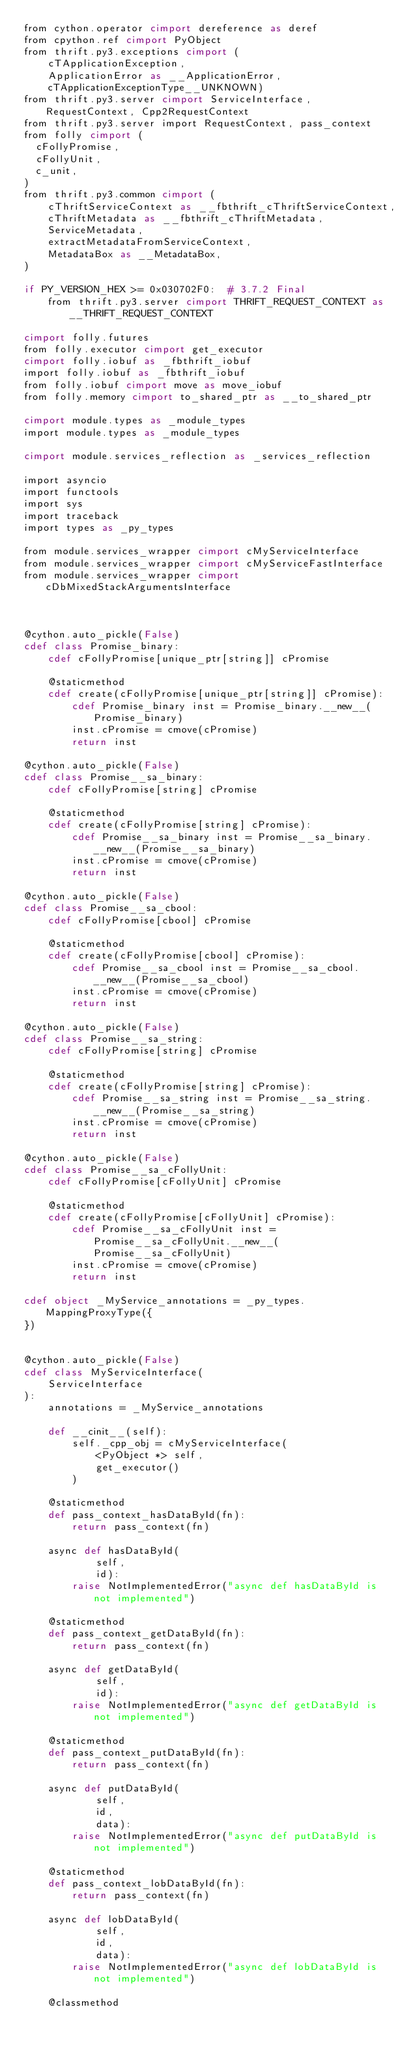Convert code to text. <code><loc_0><loc_0><loc_500><loc_500><_Cython_>from cython.operator cimport dereference as deref
from cpython.ref cimport PyObject
from thrift.py3.exceptions cimport (
    cTApplicationException,
    ApplicationError as __ApplicationError,
    cTApplicationExceptionType__UNKNOWN)
from thrift.py3.server cimport ServiceInterface, RequestContext, Cpp2RequestContext
from thrift.py3.server import RequestContext, pass_context
from folly cimport (
  cFollyPromise,
  cFollyUnit,
  c_unit,
)
from thrift.py3.common cimport (
    cThriftServiceContext as __fbthrift_cThriftServiceContext,
    cThriftMetadata as __fbthrift_cThriftMetadata,
    ServiceMetadata,
    extractMetadataFromServiceContext,
    MetadataBox as __MetadataBox,
)

if PY_VERSION_HEX >= 0x030702F0:  # 3.7.2 Final
    from thrift.py3.server cimport THRIFT_REQUEST_CONTEXT as __THRIFT_REQUEST_CONTEXT

cimport folly.futures
from folly.executor cimport get_executor
cimport folly.iobuf as _fbthrift_iobuf
import folly.iobuf as _fbthrift_iobuf
from folly.iobuf cimport move as move_iobuf
from folly.memory cimport to_shared_ptr as __to_shared_ptr

cimport module.types as _module_types
import module.types as _module_types

cimport module.services_reflection as _services_reflection

import asyncio
import functools
import sys
import traceback
import types as _py_types

from module.services_wrapper cimport cMyServiceInterface
from module.services_wrapper cimport cMyServiceFastInterface
from module.services_wrapper cimport cDbMixedStackArgumentsInterface



@cython.auto_pickle(False)
cdef class Promise_binary:
    cdef cFollyPromise[unique_ptr[string]] cPromise

    @staticmethod
    cdef create(cFollyPromise[unique_ptr[string]] cPromise):
        cdef Promise_binary inst = Promise_binary.__new__(Promise_binary)
        inst.cPromise = cmove(cPromise)
        return inst

@cython.auto_pickle(False)
cdef class Promise__sa_binary:
    cdef cFollyPromise[string] cPromise

    @staticmethod
    cdef create(cFollyPromise[string] cPromise):
        cdef Promise__sa_binary inst = Promise__sa_binary.__new__(Promise__sa_binary)
        inst.cPromise = cmove(cPromise)
        return inst

@cython.auto_pickle(False)
cdef class Promise__sa_cbool:
    cdef cFollyPromise[cbool] cPromise

    @staticmethod
    cdef create(cFollyPromise[cbool] cPromise):
        cdef Promise__sa_cbool inst = Promise__sa_cbool.__new__(Promise__sa_cbool)
        inst.cPromise = cmove(cPromise)
        return inst

@cython.auto_pickle(False)
cdef class Promise__sa_string:
    cdef cFollyPromise[string] cPromise

    @staticmethod
    cdef create(cFollyPromise[string] cPromise):
        cdef Promise__sa_string inst = Promise__sa_string.__new__(Promise__sa_string)
        inst.cPromise = cmove(cPromise)
        return inst

@cython.auto_pickle(False)
cdef class Promise__sa_cFollyUnit:
    cdef cFollyPromise[cFollyUnit] cPromise

    @staticmethod
    cdef create(cFollyPromise[cFollyUnit] cPromise):
        cdef Promise__sa_cFollyUnit inst = Promise__sa_cFollyUnit.__new__(Promise__sa_cFollyUnit)
        inst.cPromise = cmove(cPromise)
        return inst

cdef object _MyService_annotations = _py_types.MappingProxyType({
})


@cython.auto_pickle(False)
cdef class MyServiceInterface(
    ServiceInterface
):
    annotations = _MyService_annotations

    def __cinit__(self):
        self._cpp_obj = cMyServiceInterface(
            <PyObject *> self,
            get_executor()
        )

    @staticmethod
    def pass_context_hasDataById(fn):
        return pass_context(fn)

    async def hasDataById(
            self,
            id):
        raise NotImplementedError("async def hasDataById is not implemented")

    @staticmethod
    def pass_context_getDataById(fn):
        return pass_context(fn)

    async def getDataById(
            self,
            id):
        raise NotImplementedError("async def getDataById is not implemented")

    @staticmethod
    def pass_context_putDataById(fn):
        return pass_context(fn)

    async def putDataById(
            self,
            id,
            data):
        raise NotImplementedError("async def putDataById is not implemented")

    @staticmethod
    def pass_context_lobDataById(fn):
        return pass_context(fn)

    async def lobDataById(
            self,
            id,
            data):
        raise NotImplementedError("async def lobDataById is not implemented")

    @classmethod</code> 